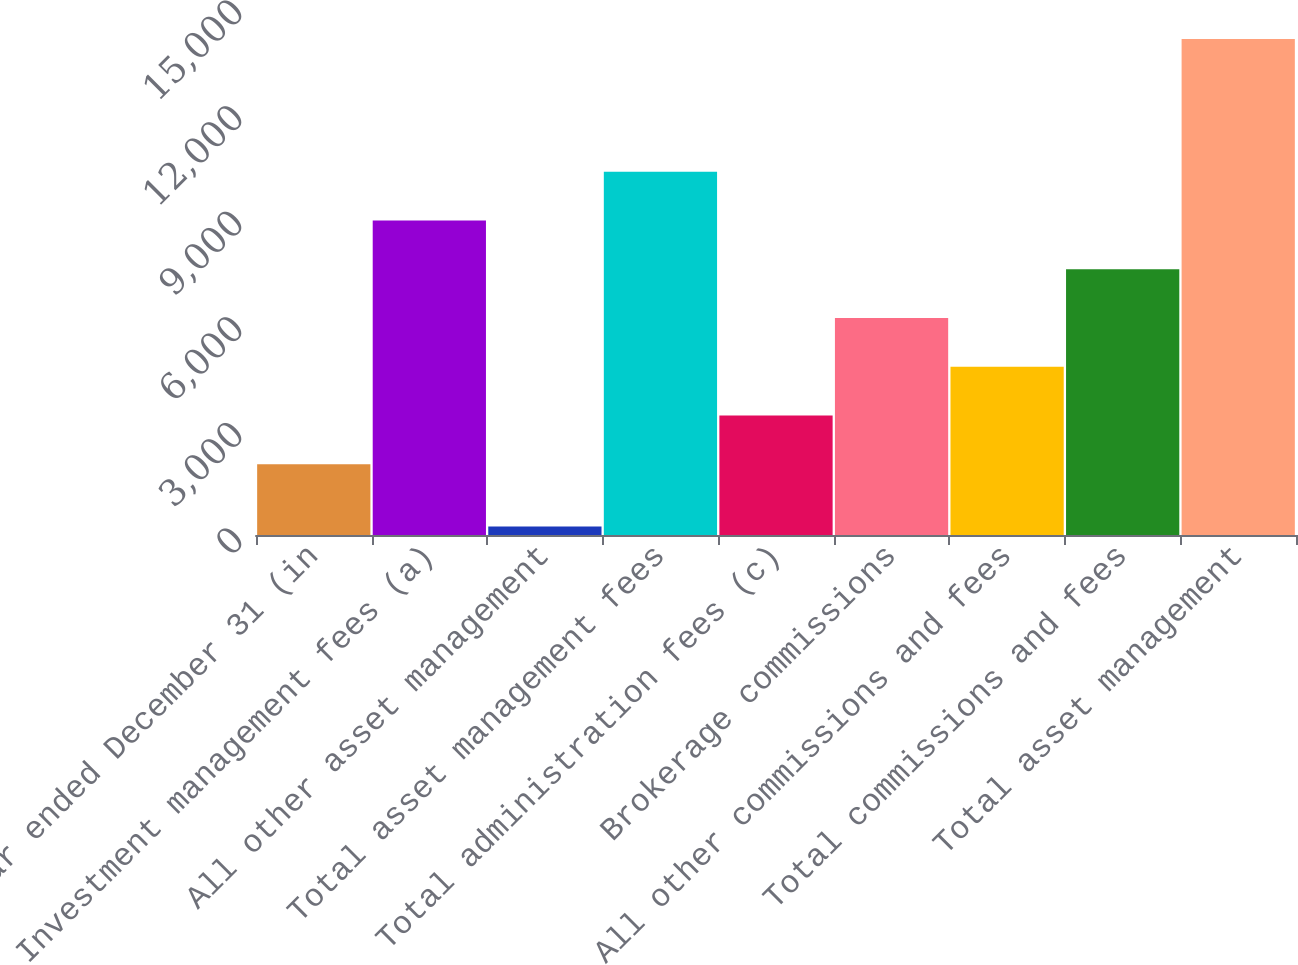<chart> <loc_0><loc_0><loc_500><loc_500><bar_chart><fcel>Year ended December 31 (in<fcel>Investment management fees (a)<fcel>All other asset management<fcel>Total asset management fees<fcel>Total administration fees (c)<fcel>Brokerage commissions<fcel>All other commissions and fees<fcel>Total commissions and fees<fcel>Total asset management<nl><fcel>2011<fcel>8937.5<fcel>241<fcel>10322.8<fcel>3396.3<fcel>6166.9<fcel>4781.6<fcel>7552.2<fcel>14094<nl></chart> 